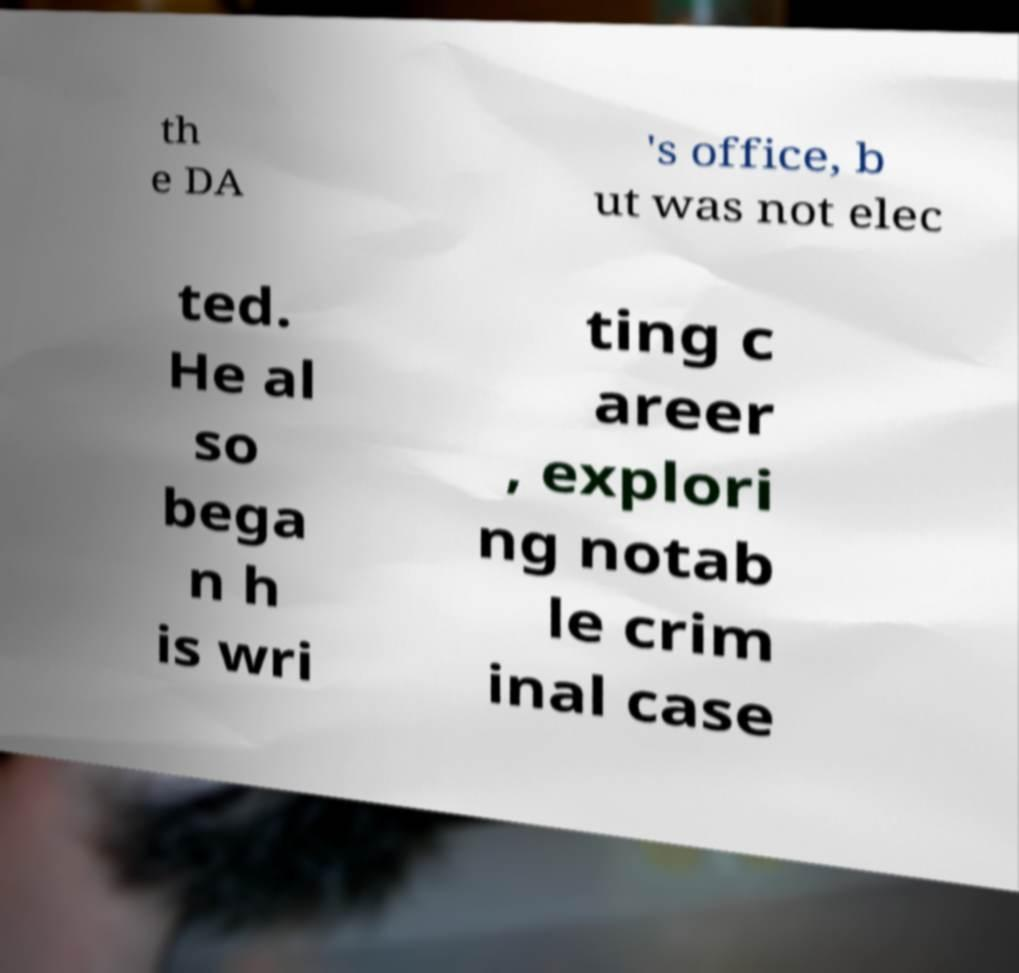There's text embedded in this image that I need extracted. Can you transcribe it verbatim? th e DA 's office, b ut was not elec ted. He al so bega n h is wri ting c areer , explori ng notab le crim inal case 